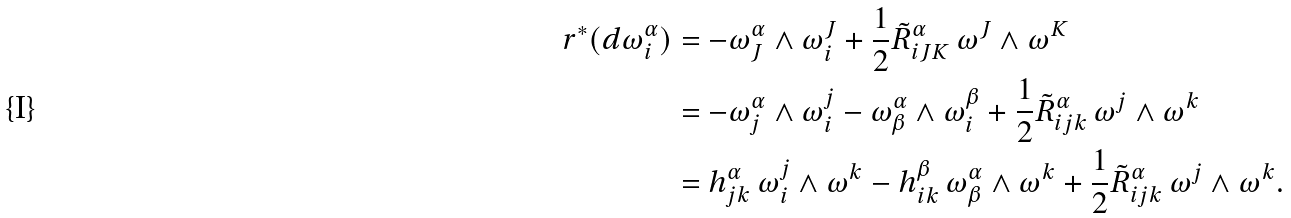<formula> <loc_0><loc_0><loc_500><loc_500>r ^ { * } ( d \omega ^ { \alpha } _ { i } ) & = - \omega ^ { \alpha } _ { J } \wedge \omega ^ { J } _ { i } + \frac { 1 } { 2 } \tilde { R } ^ { \alpha } _ { i J K } \, \omega ^ { J } \wedge \omega ^ { K } \\ & = - \omega ^ { \alpha } _ { j } \wedge \omega ^ { j } _ { i } - \omega ^ { \alpha } _ { \beta } \wedge \omega ^ { \beta } _ { i } + \frac { 1 } { 2 } \tilde { R } ^ { \alpha } _ { i j k } \, \omega ^ { j } \wedge \omega ^ { k } \\ & = h _ { j k } ^ { \alpha } \, \omega ^ { j } _ { i } \wedge \omega ^ { k } - h _ { i k } ^ { \beta } \, \omega ^ { \alpha } _ { \beta } \wedge \omega ^ { k } + \frac { 1 } { 2 } \tilde { R } ^ { \alpha } _ { i j k } \, \omega ^ { j } \wedge \omega ^ { k } .</formula> 